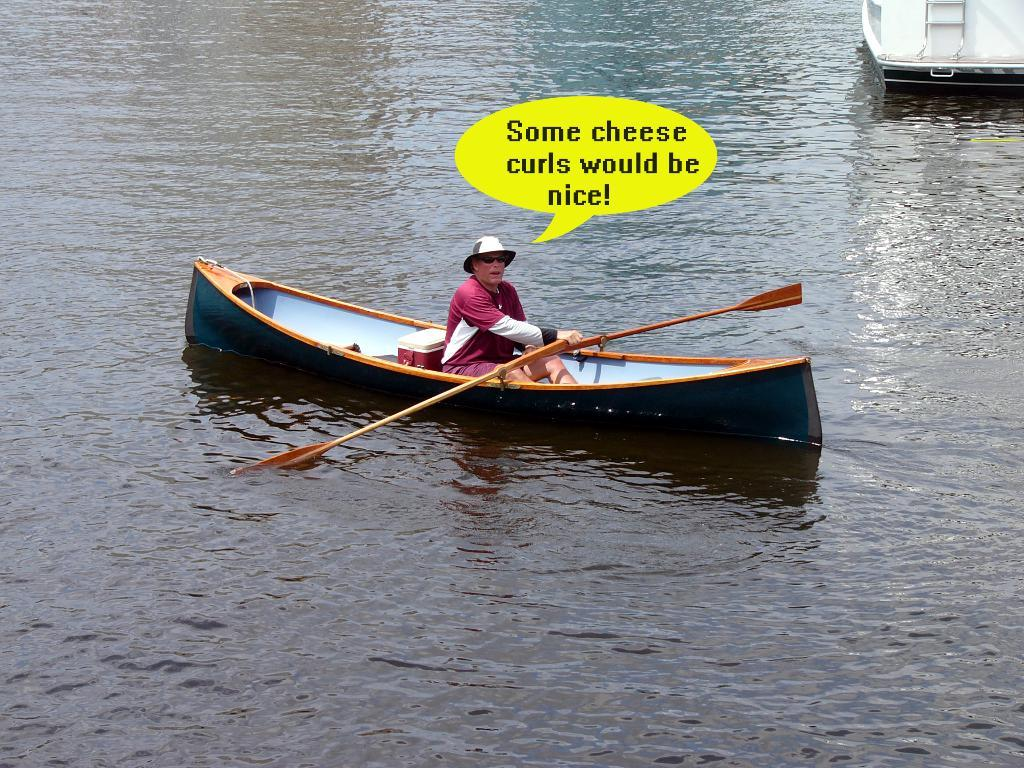What is the main subject in the center of the image? There is a boat in the center of the image. Who or what is inside the boat? There is a person sitting in the boat. What is the person doing in the boat? The person is holding a paddle. What can be seen in the background of the image? Water and the boat are visible in the background of the image. Can you see any icicles hanging from the boat in the image? There are no icicles visible in the image; it appears to be a water scene, not a cold environment. 